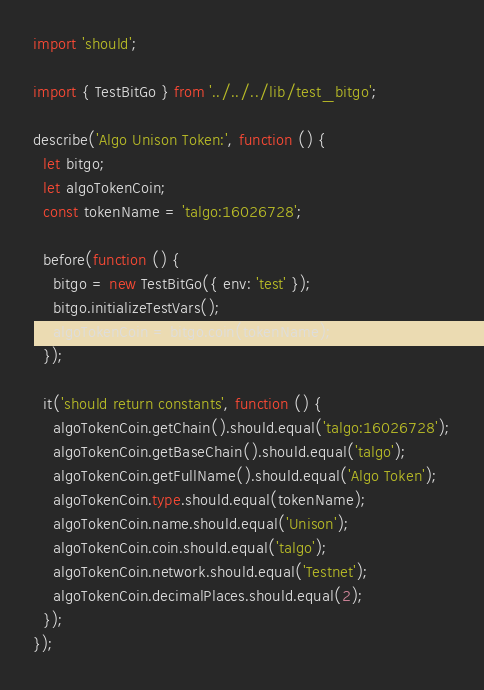Convert code to text. <code><loc_0><loc_0><loc_500><loc_500><_TypeScript_>import 'should';

import { TestBitGo } from '../../../lib/test_bitgo';

describe('Algo Unison Token:', function () {
  let bitgo;
  let algoTokenCoin;
  const tokenName = 'talgo:16026728';

  before(function () {
    bitgo = new TestBitGo({ env: 'test' });
    bitgo.initializeTestVars();
    algoTokenCoin = bitgo.coin(tokenName);
  });

  it('should return constants', function () {
    algoTokenCoin.getChain().should.equal('talgo:16026728');
    algoTokenCoin.getBaseChain().should.equal('talgo');
    algoTokenCoin.getFullName().should.equal('Algo Token');
    algoTokenCoin.type.should.equal(tokenName);
    algoTokenCoin.name.should.equal('Unison');
    algoTokenCoin.coin.should.equal('talgo');
    algoTokenCoin.network.should.equal('Testnet');
    algoTokenCoin.decimalPlaces.should.equal(2);
  });
}); 
</code> 